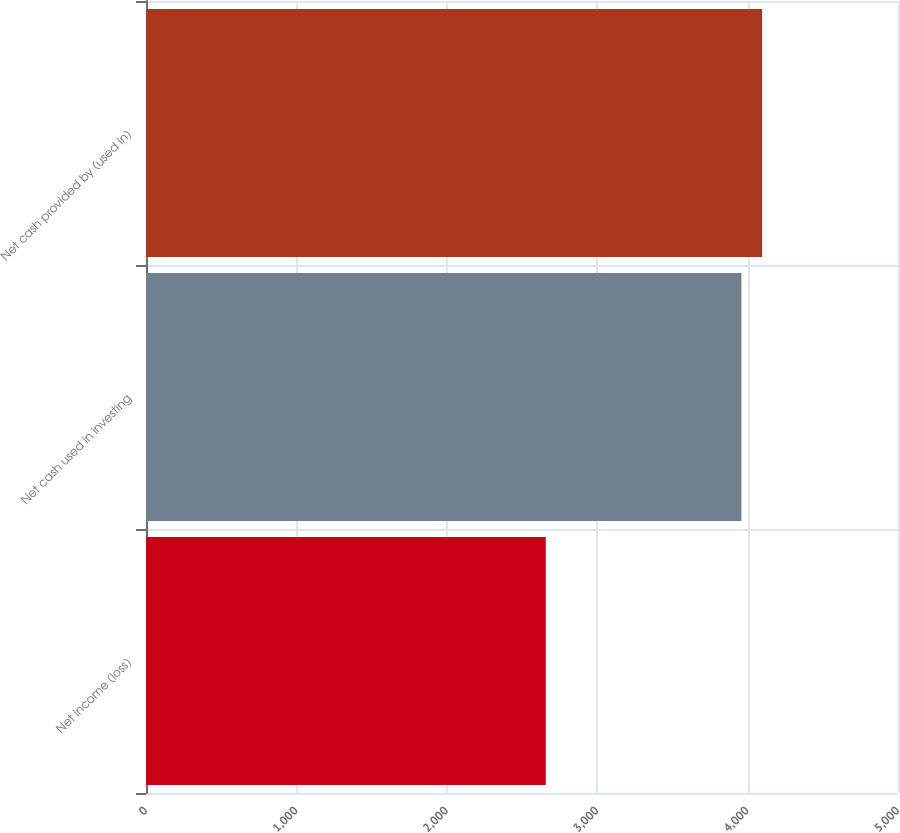<chart> <loc_0><loc_0><loc_500><loc_500><bar_chart><fcel>Net income (loss)<fcel>Net cash used in investing<fcel>Net cash provided by (used in)<nl><fcel>2658<fcel>3959<fcel>4096.3<nl></chart> 